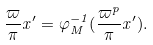<formula> <loc_0><loc_0><loc_500><loc_500>\frac { \varpi } { \pi } x ^ { \prime } = \varphi _ { M } ^ { - 1 } ( \frac { \varpi ^ { p } } \pi x ^ { \prime } ) .</formula> 